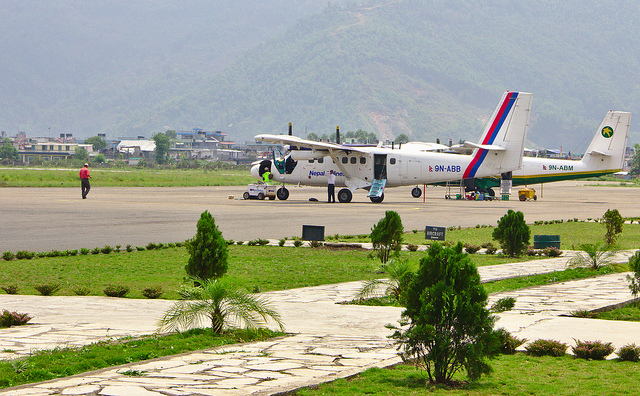Identify the text contained in this image. 9N ABM 